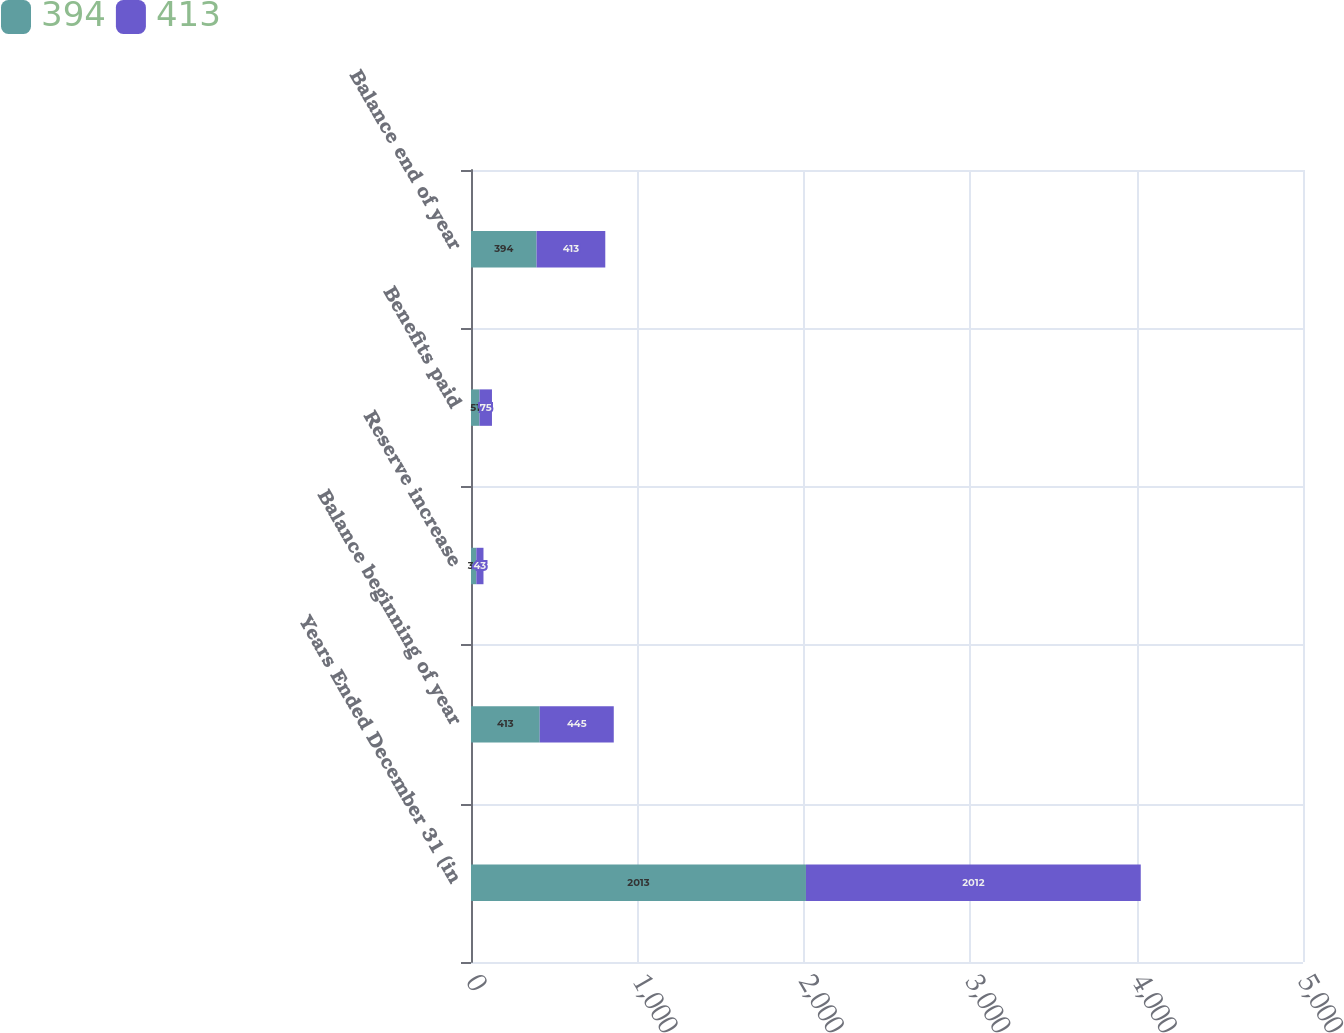Convert chart. <chart><loc_0><loc_0><loc_500><loc_500><stacked_bar_chart><ecel><fcel>Years Ended December 31 (in<fcel>Balance beginning of year<fcel>Reserve increase<fcel>Benefits paid<fcel>Balance end of year<nl><fcel>394<fcel>2013<fcel>413<fcel>32<fcel>51<fcel>394<nl><fcel>413<fcel>2012<fcel>445<fcel>43<fcel>75<fcel>413<nl></chart> 